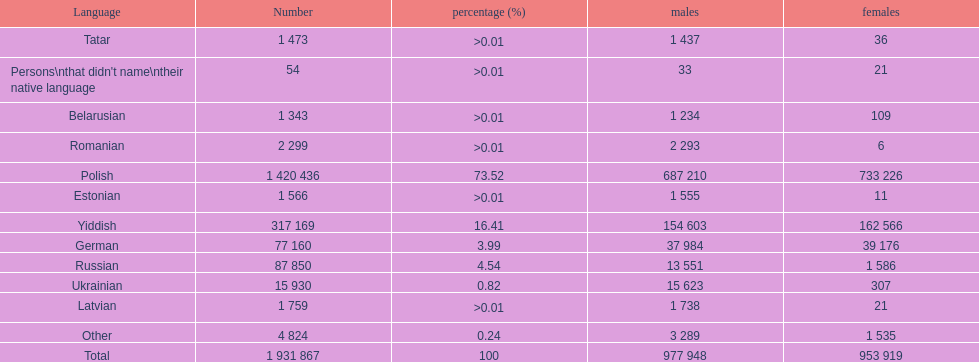What was the top language from the one's whose percentage was >0.01 Romanian. 